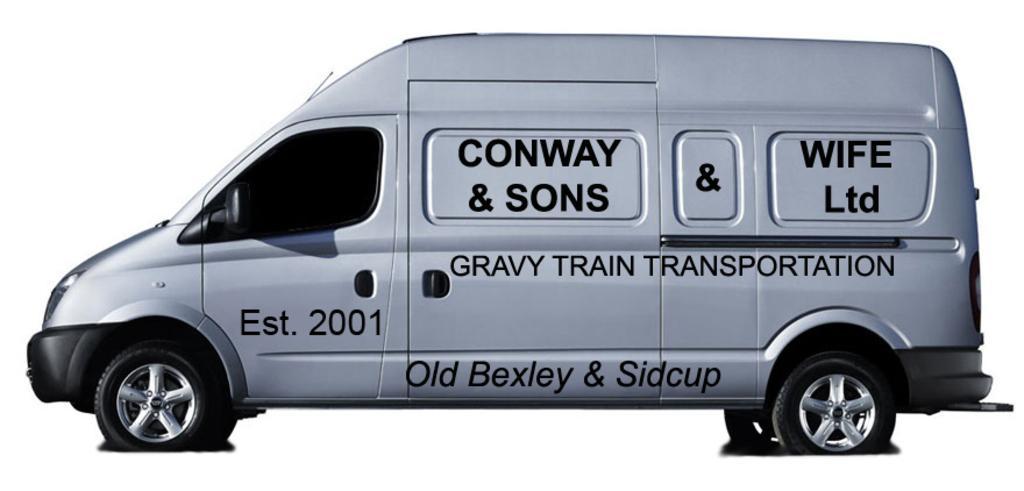How would you summarize this image in a sentence or two? In this image we can see the vehicle and we can also see the text on the vehicle and the background is in white color. 